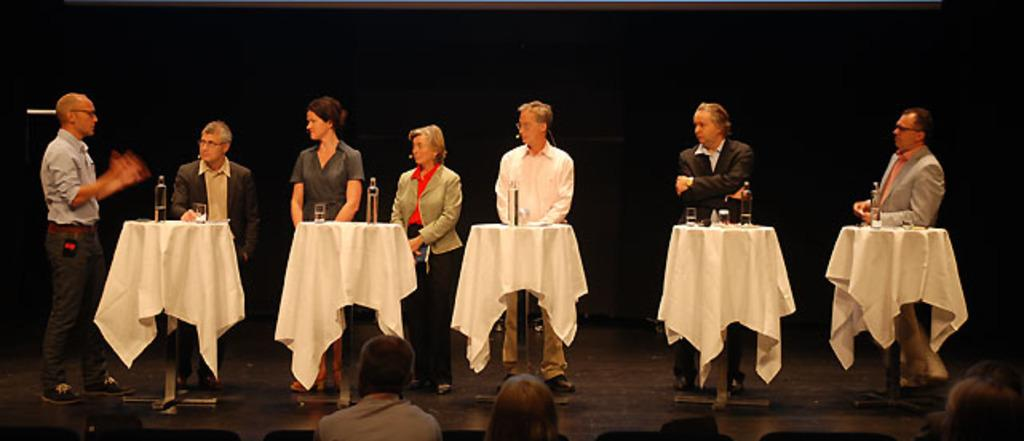What can be seen in the image involving people? There are people standing in the image, and they are part of an audience. What objects are present on the tables in the image? There are bottles, glasses, and clothes on the tables. What is the color of the background in the image? The background of the image is dark. Can you see a crown on any of the people in the image? There is no crown visible on any of the people in the image. What type of shade is being used by the audience in the image? There is no mention of any shade being used by the audience in the image. 